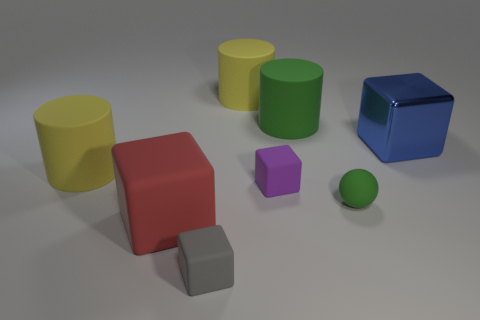Subtract all big yellow matte cylinders. How many cylinders are left? 1 Add 1 large red cylinders. How many objects exist? 9 Subtract all yellow blocks. How many yellow cylinders are left? 2 Subtract all tiny red cubes. Subtract all small purple objects. How many objects are left? 7 Add 2 large metal objects. How many large metal objects are left? 3 Add 8 tiny yellow cubes. How many tiny yellow cubes exist? 8 Subtract all yellow cylinders. How many cylinders are left? 1 Subtract 0 blue cylinders. How many objects are left? 8 Subtract all spheres. How many objects are left? 7 Subtract 1 balls. How many balls are left? 0 